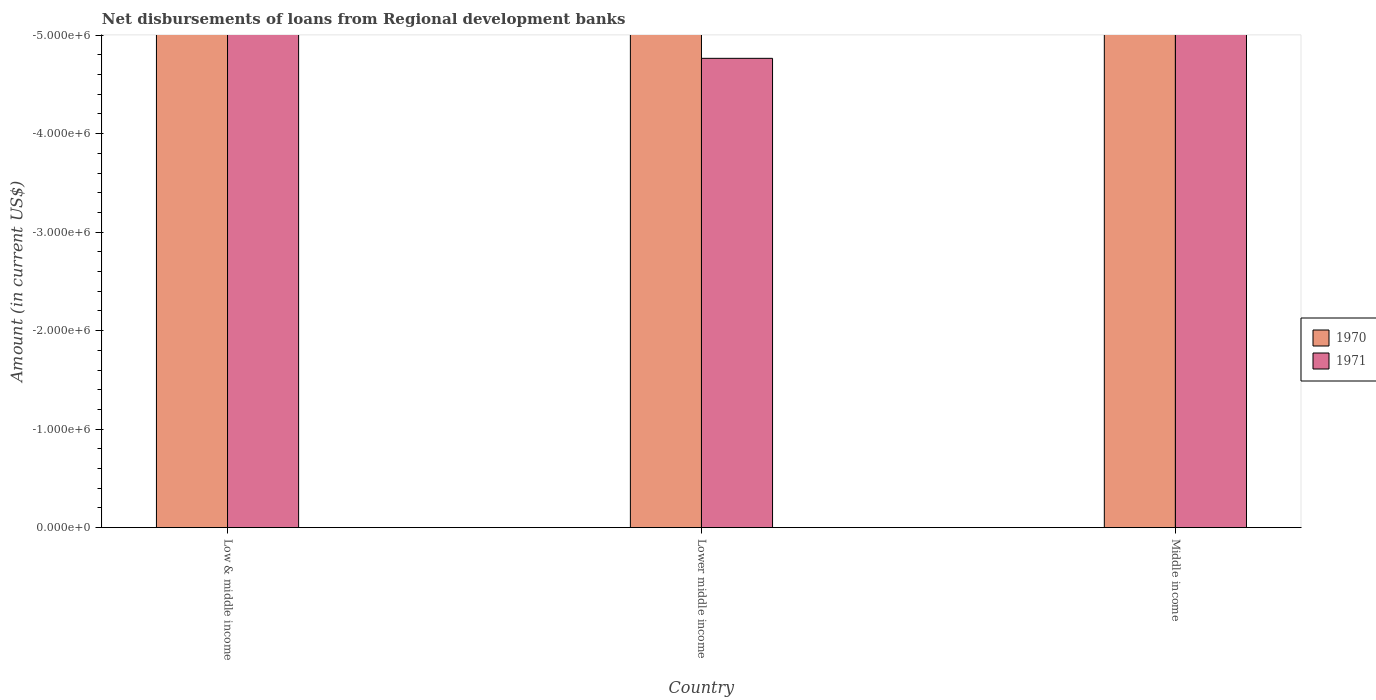How many different coloured bars are there?
Ensure brevity in your answer.  0. How many bars are there on the 3rd tick from the right?
Your answer should be very brief. 0. What is the label of the 2nd group of bars from the left?
Offer a very short reply. Lower middle income. In how many cases, is the number of bars for a given country not equal to the number of legend labels?
Give a very brief answer. 3. Across all countries, what is the minimum amount of disbursements of loans from regional development banks in 1970?
Provide a short and direct response. 0. What is the total amount of disbursements of loans from regional development banks in 1970 in the graph?
Offer a terse response. 0. What is the average amount of disbursements of loans from regional development banks in 1971 per country?
Your response must be concise. 0. Are all the bars in the graph horizontal?
Keep it short and to the point. No. How many countries are there in the graph?
Your answer should be very brief. 3. What is the difference between two consecutive major ticks on the Y-axis?
Offer a very short reply. 1.00e+06. Does the graph contain any zero values?
Your response must be concise. Yes. Does the graph contain grids?
Provide a short and direct response. No. Where does the legend appear in the graph?
Give a very brief answer. Center right. What is the title of the graph?
Your response must be concise. Net disbursements of loans from Regional development banks. What is the Amount (in current US$) in 1971 in Lower middle income?
Provide a succinct answer. 0. What is the Amount (in current US$) of 1970 in Middle income?
Your answer should be compact. 0. What is the Amount (in current US$) in 1971 in Middle income?
Your answer should be compact. 0. What is the average Amount (in current US$) of 1970 per country?
Offer a terse response. 0. 